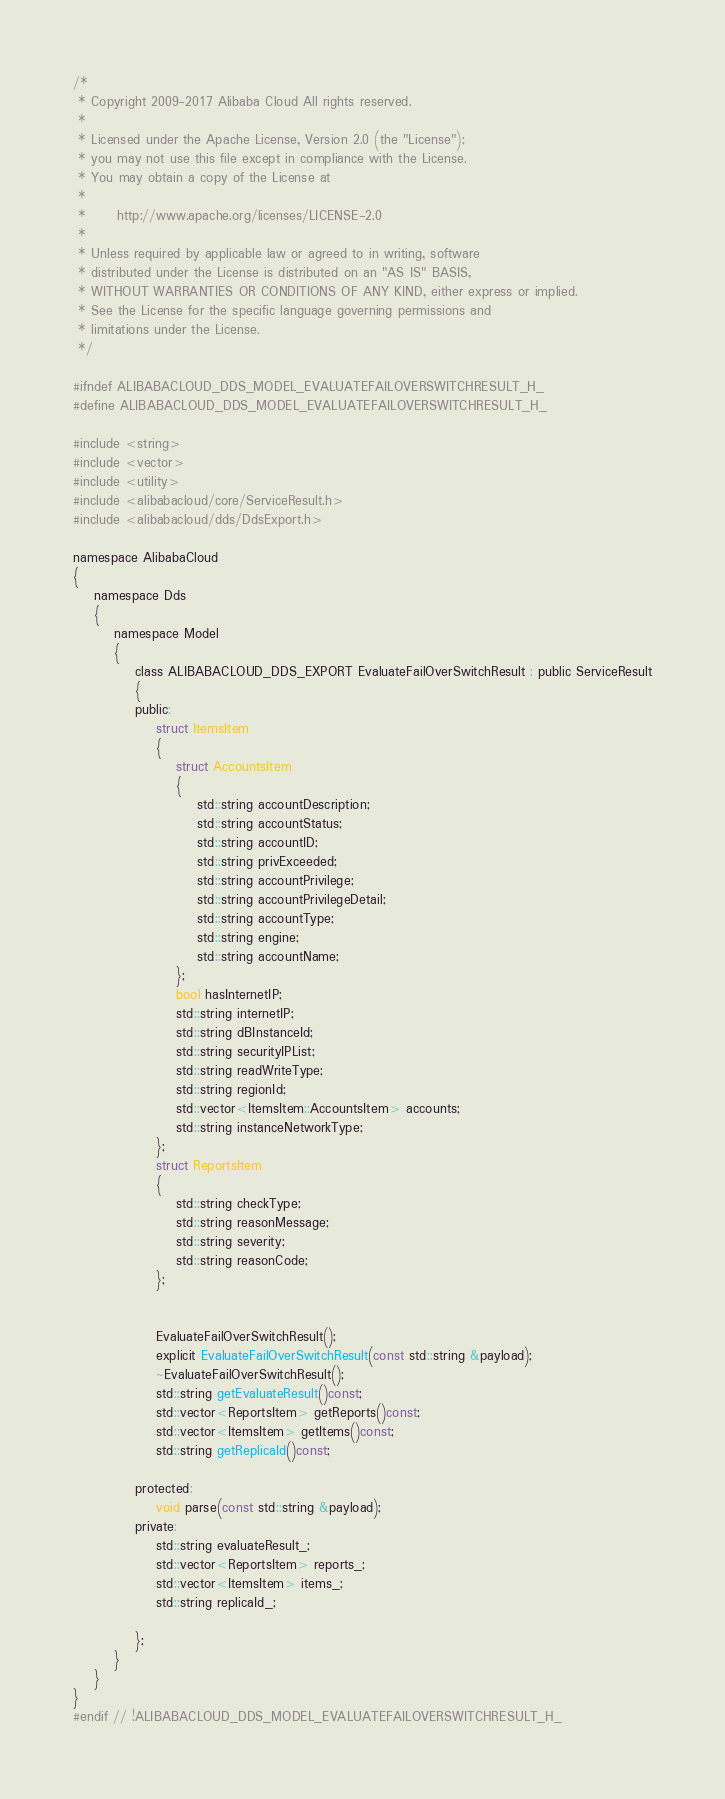Convert code to text. <code><loc_0><loc_0><loc_500><loc_500><_C_>/*
 * Copyright 2009-2017 Alibaba Cloud All rights reserved.
 * 
 * Licensed under the Apache License, Version 2.0 (the "License");
 * you may not use this file except in compliance with the License.
 * You may obtain a copy of the License at
 * 
 *      http://www.apache.org/licenses/LICENSE-2.0
 * 
 * Unless required by applicable law or agreed to in writing, software
 * distributed under the License is distributed on an "AS IS" BASIS,
 * WITHOUT WARRANTIES OR CONDITIONS OF ANY KIND, either express or implied.
 * See the License for the specific language governing permissions and
 * limitations under the License.
 */

#ifndef ALIBABACLOUD_DDS_MODEL_EVALUATEFAILOVERSWITCHRESULT_H_
#define ALIBABACLOUD_DDS_MODEL_EVALUATEFAILOVERSWITCHRESULT_H_

#include <string>
#include <vector>
#include <utility>
#include <alibabacloud/core/ServiceResult.h>
#include <alibabacloud/dds/DdsExport.h>

namespace AlibabaCloud
{
	namespace Dds
	{
		namespace Model
		{
			class ALIBABACLOUD_DDS_EXPORT EvaluateFailOverSwitchResult : public ServiceResult
			{
			public:
				struct ItemsItem
				{
					struct AccountsItem
					{
						std::string accountDescription;
						std::string accountStatus;
						std::string accountID;
						std::string privExceeded;
						std::string accountPrivilege;
						std::string accountPrivilegeDetail;
						std::string accountType;
						std::string engine;
						std::string accountName;
					};
					bool hasInternetIP;
					std::string internetIP;
					std::string dBInstanceId;
					std::string securityIPList;
					std::string readWriteType;
					std::string regionId;
					std::vector<ItemsItem::AccountsItem> accounts;
					std::string instanceNetworkType;
				};
				struct ReportsItem
				{
					std::string checkType;
					std::string reasonMessage;
					std::string severity;
					std::string reasonCode;
				};


				EvaluateFailOverSwitchResult();
				explicit EvaluateFailOverSwitchResult(const std::string &payload);
				~EvaluateFailOverSwitchResult();
				std::string getEvaluateResult()const;
				std::vector<ReportsItem> getReports()const;
				std::vector<ItemsItem> getItems()const;
				std::string getReplicaId()const;

			protected:
				void parse(const std::string &payload);
			private:
				std::string evaluateResult_;
				std::vector<ReportsItem> reports_;
				std::vector<ItemsItem> items_;
				std::string replicaId_;

			};
		}
	}
}
#endif // !ALIBABACLOUD_DDS_MODEL_EVALUATEFAILOVERSWITCHRESULT_H_</code> 